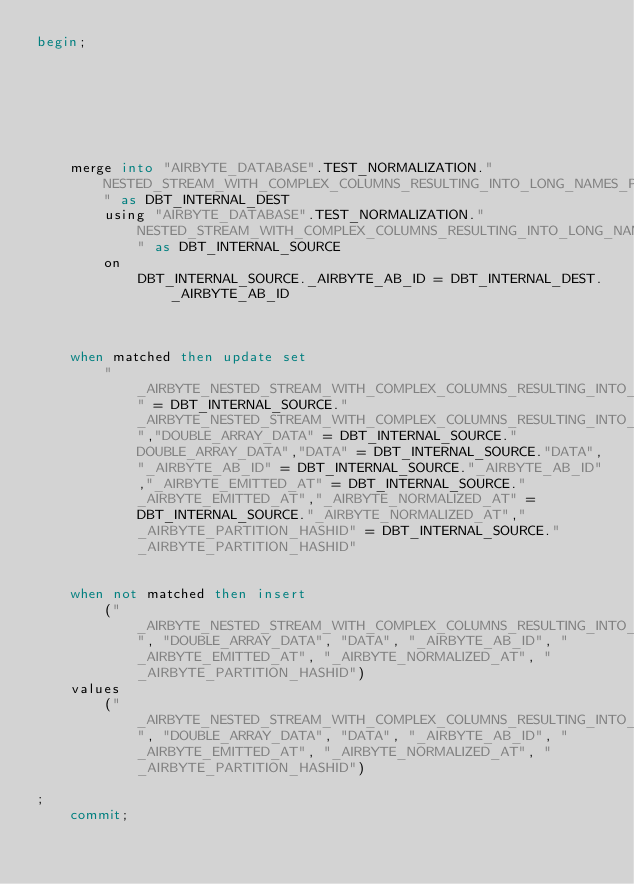<code> <loc_0><loc_0><loc_500><loc_500><_SQL_>begin;
    
        
        
    

    

    merge into "AIRBYTE_DATABASE".TEST_NORMALIZATION."NESTED_STREAM_WITH_COMPLEX_COLUMNS_RESULTING_INTO_LONG_NAMES_PARTITION" as DBT_INTERNAL_DEST
        using "AIRBYTE_DATABASE".TEST_NORMALIZATION."NESTED_STREAM_WITH_COMPLEX_COLUMNS_RESULTING_INTO_LONG_NAMES_PARTITION__dbt_tmp" as DBT_INTERNAL_SOURCE
        on 
            DBT_INTERNAL_SOURCE._AIRBYTE_AB_ID = DBT_INTERNAL_DEST._AIRBYTE_AB_ID
        

    
    when matched then update set
        "_AIRBYTE_NESTED_STREAM_WITH_COMPLEX_COLUMNS_RESULTING_INTO_LONG_NAMES_HASHID" = DBT_INTERNAL_SOURCE."_AIRBYTE_NESTED_STREAM_WITH_COMPLEX_COLUMNS_RESULTING_INTO_LONG_NAMES_HASHID","DOUBLE_ARRAY_DATA" = DBT_INTERNAL_SOURCE."DOUBLE_ARRAY_DATA","DATA" = DBT_INTERNAL_SOURCE."DATA","_AIRBYTE_AB_ID" = DBT_INTERNAL_SOURCE."_AIRBYTE_AB_ID","_AIRBYTE_EMITTED_AT" = DBT_INTERNAL_SOURCE."_AIRBYTE_EMITTED_AT","_AIRBYTE_NORMALIZED_AT" = DBT_INTERNAL_SOURCE."_AIRBYTE_NORMALIZED_AT","_AIRBYTE_PARTITION_HASHID" = DBT_INTERNAL_SOURCE."_AIRBYTE_PARTITION_HASHID"
    

    when not matched then insert
        ("_AIRBYTE_NESTED_STREAM_WITH_COMPLEX_COLUMNS_RESULTING_INTO_LONG_NAMES_HASHID", "DOUBLE_ARRAY_DATA", "DATA", "_AIRBYTE_AB_ID", "_AIRBYTE_EMITTED_AT", "_AIRBYTE_NORMALIZED_AT", "_AIRBYTE_PARTITION_HASHID")
    values
        ("_AIRBYTE_NESTED_STREAM_WITH_COMPLEX_COLUMNS_RESULTING_INTO_LONG_NAMES_HASHID", "DOUBLE_ARRAY_DATA", "DATA", "_AIRBYTE_AB_ID", "_AIRBYTE_EMITTED_AT", "_AIRBYTE_NORMALIZED_AT", "_AIRBYTE_PARTITION_HASHID")

;
    commit;</code> 